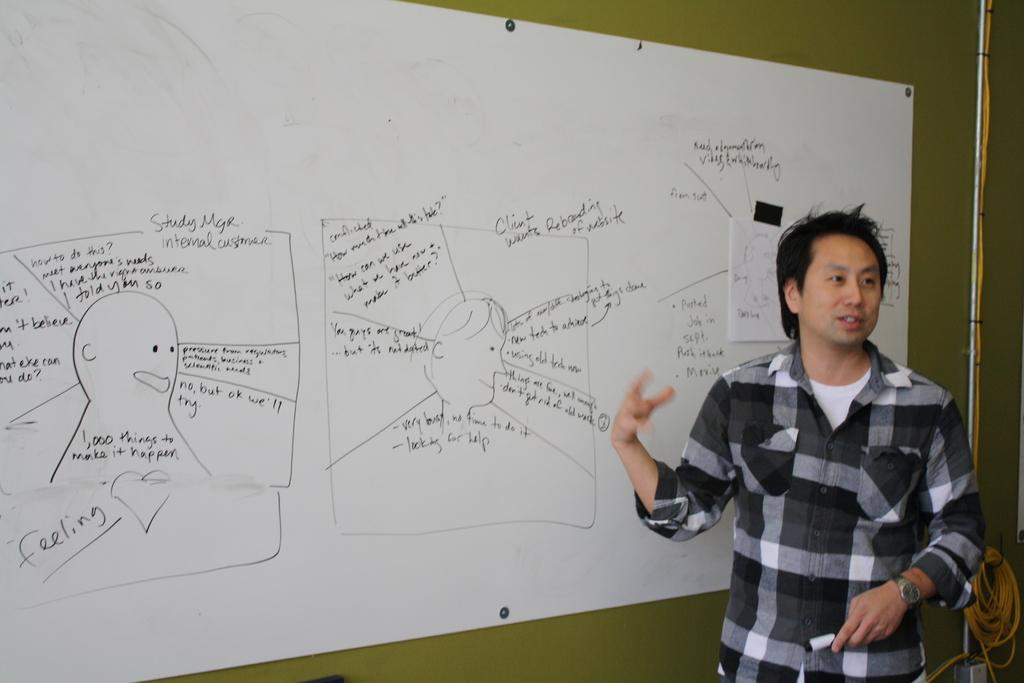What is the man in the image doing? The man is standing and talking in the image. What can be seen on the wall in the image? There is a board on a wall in the image. What object is visible that resembles a long, thin bar? There is a rod visible in the image. What type of flexible material is present in the image? There is a rope in the image. What type of brake can be seen on the man's bicycle in the image? There is no bicycle present in the image, so it is not possible to determine if there is a brake or what type it might be. 